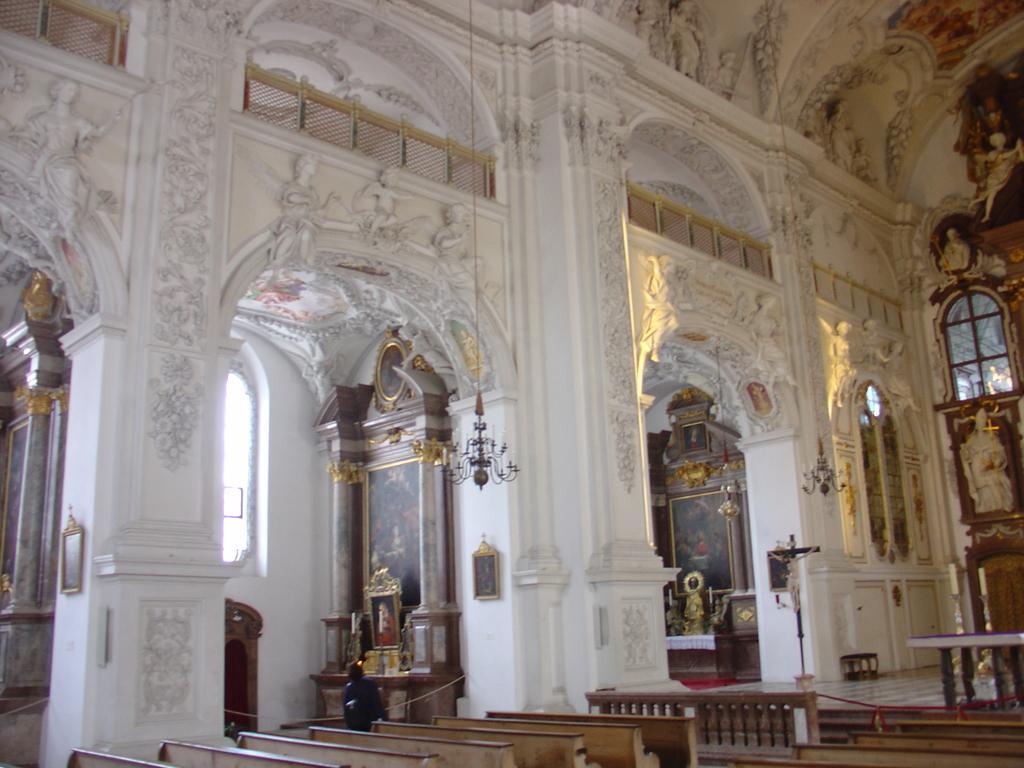Describe this image in one or two sentences. In this image I can see the interior of the building. I can see few benches which are brown in color, the floor, few statues, few pillars, few windows, the railing, few photo frames and few other objects. 